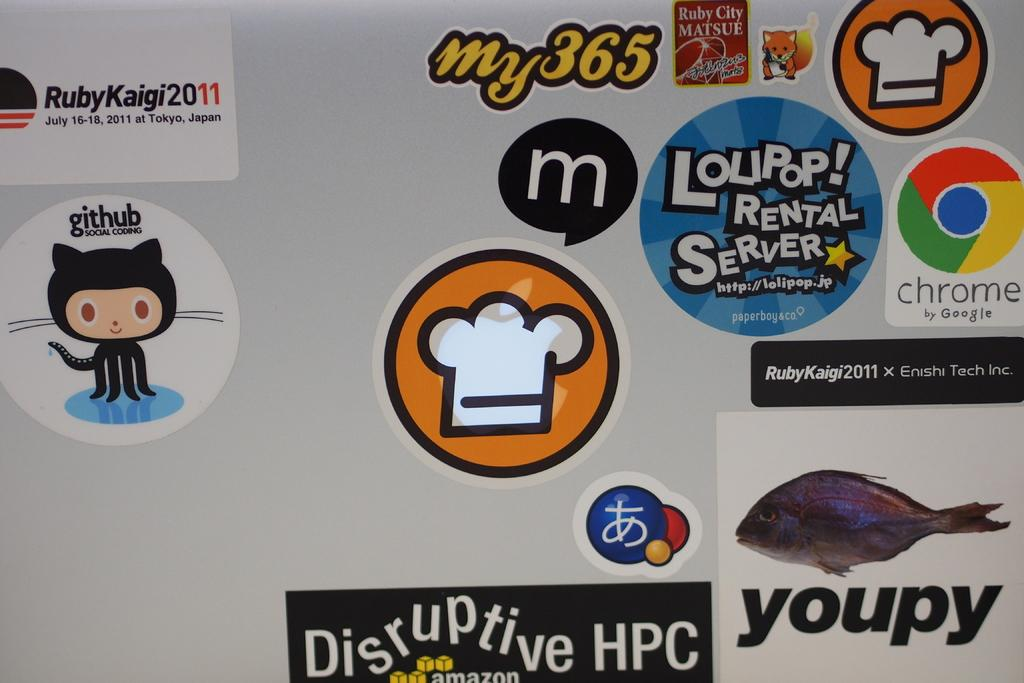What is featured on the poster in the image? There is a poster in the image, which contains text, a picture of a fish, logos, and symbols. Can you describe the main image on the poster? The main image on the poster is a picture of a fish. What else can be found on the poster besides the fish image? The poster contains text, logos, and symbols. How many cent buns are visible in the image? There are no cent buns present in the image. What type of copy machine is used to print the poster in the image? There is no information about a copy machine in the image; it only features a poster with various elements. 